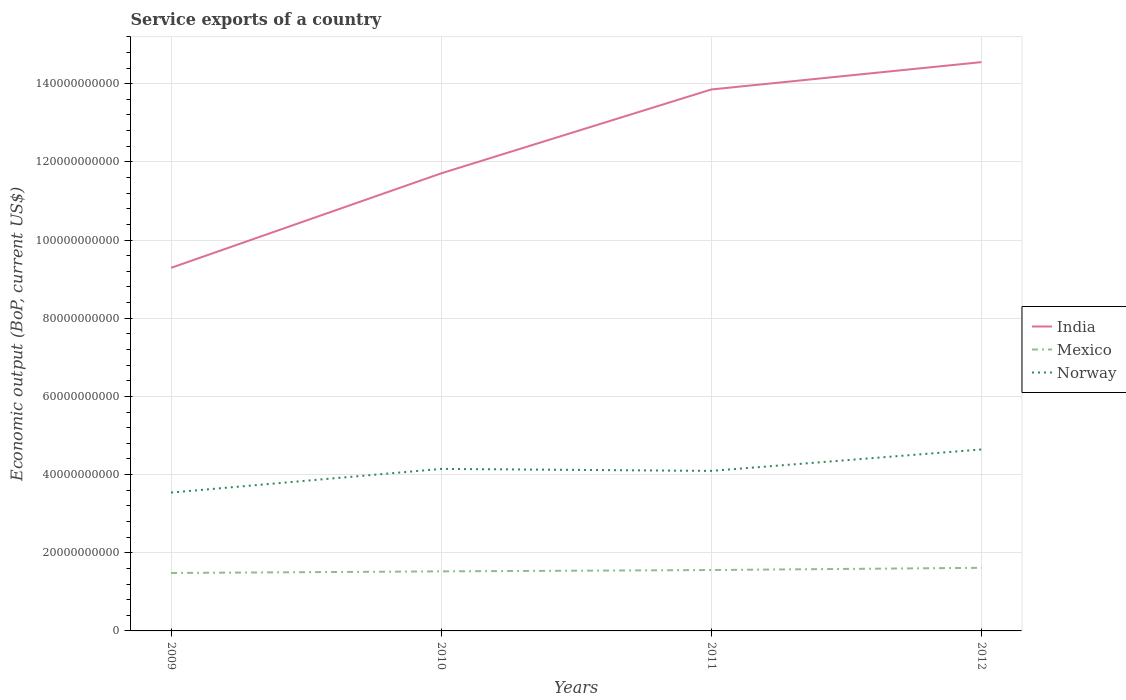How many different coloured lines are there?
Give a very brief answer. 3. Does the line corresponding to Mexico intersect with the line corresponding to India?
Your answer should be compact. No. Across all years, what is the maximum service exports in Norway?
Your answer should be very brief. 3.54e+1. In which year was the service exports in India maximum?
Your response must be concise. 2009. What is the total service exports in India in the graph?
Make the answer very short. -2.85e+1. What is the difference between the highest and the second highest service exports in Norway?
Provide a succinct answer. 1.10e+1. Is the service exports in India strictly greater than the service exports in Mexico over the years?
Make the answer very short. No. How many lines are there?
Your answer should be compact. 3. What is the difference between two consecutive major ticks on the Y-axis?
Your answer should be compact. 2.00e+1. Does the graph contain any zero values?
Keep it short and to the point. No. Does the graph contain grids?
Your response must be concise. Yes. Where does the legend appear in the graph?
Your response must be concise. Center right. How are the legend labels stacked?
Keep it short and to the point. Vertical. What is the title of the graph?
Offer a very short reply. Service exports of a country. What is the label or title of the Y-axis?
Give a very brief answer. Economic output (BoP, current US$). What is the Economic output (BoP, current US$) in India in 2009?
Keep it short and to the point. 9.29e+1. What is the Economic output (BoP, current US$) of Mexico in 2009?
Your answer should be compact. 1.48e+1. What is the Economic output (BoP, current US$) in Norway in 2009?
Ensure brevity in your answer.  3.54e+1. What is the Economic output (BoP, current US$) in India in 2010?
Provide a short and direct response. 1.17e+11. What is the Economic output (BoP, current US$) of Mexico in 2010?
Provide a short and direct response. 1.52e+1. What is the Economic output (BoP, current US$) of Norway in 2010?
Keep it short and to the point. 4.15e+1. What is the Economic output (BoP, current US$) in India in 2011?
Your answer should be compact. 1.39e+11. What is the Economic output (BoP, current US$) in Mexico in 2011?
Your answer should be very brief. 1.56e+1. What is the Economic output (BoP, current US$) of Norway in 2011?
Your response must be concise. 4.09e+1. What is the Economic output (BoP, current US$) of India in 2012?
Provide a succinct answer. 1.46e+11. What is the Economic output (BoP, current US$) of Mexico in 2012?
Provide a short and direct response. 1.61e+1. What is the Economic output (BoP, current US$) in Norway in 2012?
Provide a short and direct response. 4.64e+1. Across all years, what is the maximum Economic output (BoP, current US$) in India?
Make the answer very short. 1.46e+11. Across all years, what is the maximum Economic output (BoP, current US$) in Mexico?
Keep it short and to the point. 1.61e+1. Across all years, what is the maximum Economic output (BoP, current US$) in Norway?
Your response must be concise. 4.64e+1. Across all years, what is the minimum Economic output (BoP, current US$) in India?
Provide a succinct answer. 9.29e+1. Across all years, what is the minimum Economic output (BoP, current US$) in Mexico?
Provide a short and direct response. 1.48e+1. Across all years, what is the minimum Economic output (BoP, current US$) of Norway?
Make the answer very short. 3.54e+1. What is the total Economic output (BoP, current US$) of India in the graph?
Your answer should be compact. 4.94e+11. What is the total Economic output (BoP, current US$) in Mexico in the graph?
Provide a succinct answer. 6.18e+1. What is the total Economic output (BoP, current US$) in Norway in the graph?
Offer a terse response. 1.64e+11. What is the difference between the Economic output (BoP, current US$) of India in 2009 and that in 2010?
Offer a very short reply. -2.42e+1. What is the difference between the Economic output (BoP, current US$) of Mexico in 2009 and that in 2010?
Provide a short and direct response. -4.10e+08. What is the difference between the Economic output (BoP, current US$) in Norway in 2009 and that in 2010?
Make the answer very short. -6.06e+09. What is the difference between the Economic output (BoP, current US$) in India in 2009 and that in 2011?
Give a very brief answer. -4.56e+1. What is the difference between the Economic output (BoP, current US$) in Mexico in 2009 and that in 2011?
Your answer should be very brief. -7.58e+08. What is the difference between the Economic output (BoP, current US$) in Norway in 2009 and that in 2011?
Give a very brief answer. -5.54e+09. What is the difference between the Economic output (BoP, current US$) of India in 2009 and that in 2012?
Your answer should be very brief. -5.26e+1. What is the difference between the Economic output (BoP, current US$) of Mexico in 2009 and that in 2012?
Offer a terse response. -1.32e+09. What is the difference between the Economic output (BoP, current US$) of Norway in 2009 and that in 2012?
Your answer should be compact. -1.10e+1. What is the difference between the Economic output (BoP, current US$) of India in 2010 and that in 2011?
Offer a very short reply. -2.15e+1. What is the difference between the Economic output (BoP, current US$) in Mexico in 2010 and that in 2011?
Make the answer very short. -3.47e+08. What is the difference between the Economic output (BoP, current US$) of Norway in 2010 and that in 2011?
Provide a succinct answer. 5.11e+08. What is the difference between the Economic output (BoP, current US$) of India in 2010 and that in 2012?
Your answer should be compact. -2.85e+1. What is the difference between the Economic output (BoP, current US$) of Mexico in 2010 and that in 2012?
Make the answer very short. -9.11e+08. What is the difference between the Economic output (BoP, current US$) in Norway in 2010 and that in 2012?
Provide a succinct answer. -4.97e+09. What is the difference between the Economic output (BoP, current US$) in India in 2011 and that in 2012?
Your answer should be very brief. -7.00e+09. What is the difference between the Economic output (BoP, current US$) in Mexico in 2011 and that in 2012?
Make the answer very short. -5.64e+08. What is the difference between the Economic output (BoP, current US$) in Norway in 2011 and that in 2012?
Your answer should be very brief. -5.48e+09. What is the difference between the Economic output (BoP, current US$) of India in 2009 and the Economic output (BoP, current US$) of Mexico in 2010?
Give a very brief answer. 7.77e+1. What is the difference between the Economic output (BoP, current US$) in India in 2009 and the Economic output (BoP, current US$) in Norway in 2010?
Provide a short and direct response. 5.14e+1. What is the difference between the Economic output (BoP, current US$) in Mexico in 2009 and the Economic output (BoP, current US$) in Norway in 2010?
Offer a terse response. -2.66e+1. What is the difference between the Economic output (BoP, current US$) in India in 2009 and the Economic output (BoP, current US$) in Mexico in 2011?
Offer a very short reply. 7.73e+1. What is the difference between the Economic output (BoP, current US$) of India in 2009 and the Economic output (BoP, current US$) of Norway in 2011?
Provide a succinct answer. 5.19e+1. What is the difference between the Economic output (BoP, current US$) in Mexico in 2009 and the Economic output (BoP, current US$) in Norway in 2011?
Keep it short and to the point. -2.61e+1. What is the difference between the Economic output (BoP, current US$) of India in 2009 and the Economic output (BoP, current US$) of Mexico in 2012?
Give a very brief answer. 7.67e+1. What is the difference between the Economic output (BoP, current US$) in India in 2009 and the Economic output (BoP, current US$) in Norway in 2012?
Provide a succinct answer. 4.65e+1. What is the difference between the Economic output (BoP, current US$) of Mexico in 2009 and the Economic output (BoP, current US$) of Norway in 2012?
Keep it short and to the point. -3.16e+1. What is the difference between the Economic output (BoP, current US$) of India in 2010 and the Economic output (BoP, current US$) of Mexico in 2011?
Provide a short and direct response. 1.01e+11. What is the difference between the Economic output (BoP, current US$) in India in 2010 and the Economic output (BoP, current US$) in Norway in 2011?
Provide a succinct answer. 7.61e+1. What is the difference between the Economic output (BoP, current US$) of Mexico in 2010 and the Economic output (BoP, current US$) of Norway in 2011?
Your answer should be very brief. -2.57e+1. What is the difference between the Economic output (BoP, current US$) of India in 2010 and the Economic output (BoP, current US$) of Mexico in 2012?
Your answer should be very brief. 1.01e+11. What is the difference between the Economic output (BoP, current US$) of India in 2010 and the Economic output (BoP, current US$) of Norway in 2012?
Offer a terse response. 7.06e+1. What is the difference between the Economic output (BoP, current US$) of Mexico in 2010 and the Economic output (BoP, current US$) of Norway in 2012?
Provide a short and direct response. -3.12e+1. What is the difference between the Economic output (BoP, current US$) in India in 2011 and the Economic output (BoP, current US$) in Mexico in 2012?
Make the answer very short. 1.22e+11. What is the difference between the Economic output (BoP, current US$) in India in 2011 and the Economic output (BoP, current US$) in Norway in 2012?
Provide a short and direct response. 9.21e+1. What is the difference between the Economic output (BoP, current US$) in Mexico in 2011 and the Economic output (BoP, current US$) in Norway in 2012?
Your answer should be very brief. -3.08e+1. What is the average Economic output (BoP, current US$) in India per year?
Make the answer very short. 1.24e+11. What is the average Economic output (BoP, current US$) of Mexico per year?
Provide a short and direct response. 1.54e+1. What is the average Economic output (BoP, current US$) in Norway per year?
Ensure brevity in your answer.  4.11e+1. In the year 2009, what is the difference between the Economic output (BoP, current US$) of India and Economic output (BoP, current US$) of Mexico?
Provide a short and direct response. 7.81e+1. In the year 2009, what is the difference between the Economic output (BoP, current US$) in India and Economic output (BoP, current US$) in Norway?
Offer a terse response. 5.75e+1. In the year 2009, what is the difference between the Economic output (BoP, current US$) in Mexico and Economic output (BoP, current US$) in Norway?
Keep it short and to the point. -2.06e+1. In the year 2010, what is the difference between the Economic output (BoP, current US$) in India and Economic output (BoP, current US$) in Mexico?
Your answer should be very brief. 1.02e+11. In the year 2010, what is the difference between the Economic output (BoP, current US$) of India and Economic output (BoP, current US$) of Norway?
Keep it short and to the point. 7.56e+1. In the year 2010, what is the difference between the Economic output (BoP, current US$) of Mexico and Economic output (BoP, current US$) of Norway?
Your response must be concise. -2.62e+1. In the year 2011, what is the difference between the Economic output (BoP, current US$) in India and Economic output (BoP, current US$) in Mexico?
Provide a succinct answer. 1.23e+11. In the year 2011, what is the difference between the Economic output (BoP, current US$) of India and Economic output (BoP, current US$) of Norway?
Offer a terse response. 9.76e+1. In the year 2011, what is the difference between the Economic output (BoP, current US$) of Mexico and Economic output (BoP, current US$) of Norway?
Ensure brevity in your answer.  -2.54e+1. In the year 2012, what is the difference between the Economic output (BoP, current US$) in India and Economic output (BoP, current US$) in Mexico?
Offer a terse response. 1.29e+11. In the year 2012, what is the difference between the Economic output (BoP, current US$) of India and Economic output (BoP, current US$) of Norway?
Your answer should be very brief. 9.91e+1. In the year 2012, what is the difference between the Economic output (BoP, current US$) of Mexico and Economic output (BoP, current US$) of Norway?
Make the answer very short. -3.03e+1. What is the ratio of the Economic output (BoP, current US$) in India in 2009 to that in 2010?
Offer a very short reply. 0.79. What is the ratio of the Economic output (BoP, current US$) of Mexico in 2009 to that in 2010?
Offer a terse response. 0.97. What is the ratio of the Economic output (BoP, current US$) of Norway in 2009 to that in 2010?
Your answer should be compact. 0.85. What is the ratio of the Economic output (BoP, current US$) in India in 2009 to that in 2011?
Provide a succinct answer. 0.67. What is the ratio of the Economic output (BoP, current US$) of Mexico in 2009 to that in 2011?
Your answer should be very brief. 0.95. What is the ratio of the Economic output (BoP, current US$) of Norway in 2009 to that in 2011?
Keep it short and to the point. 0.86. What is the ratio of the Economic output (BoP, current US$) of India in 2009 to that in 2012?
Your answer should be very brief. 0.64. What is the ratio of the Economic output (BoP, current US$) in Mexico in 2009 to that in 2012?
Keep it short and to the point. 0.92. What is the ratio of the Economic output (BoP, current US$) in Norway in 2009 to that in 2012?
Offer a very short reply. 0.76. What is the ratio of the Economic output (BoP, current US$) of India in 2010 to that in 2011?
Your answer should be very brief. 0.85. What is the ratio of the Economic output (BoP, current US$) in Mexico in 2010 to that in 2011?
Your answer should be very brief. 0.98. What is the ratio of the Economic output (BoP, current US$) in Norway in 2010 to that in 2011?
Offer a very short reply. 1.01. What is the ratio of the Economic output (BoP, current US$) in India in 2010 to that in 2012?
Offer a terse response. 0.8. What is the ratio of the Economic output (BoP, current US$) in Mexico in 2010 to that in 2012?
Offer a terse response. 0.94. What is the ratio of the Economic output (BoP, current US$) of Norway in 2010 to that in 2012?
Offer a very short reply. 0.89. What is the ratio of the Economic output (BoP, current US$) of India in 2011 to that in 2012?
Keep it short and to the point. 0.95. What is the ratio of the Economic output (BoP, current US$) of Mexico in 2011 to that in 2012?
Your response must be concise. 0.97. What is the ratio of the Economic output (BoP, current US$) in Norway in 2011 to that in 2012?
Keep it short and to the point. 0.88. What is the difference between the highest and the second highest Economic output (BoP, current US$) in India?
Provide a succinct answer. 7.00e+09. What is the difference between the highest and the second highest Economic output (BoP, current US$) of Mexico?
Give a very brief answer. 5.64e+08. What is the difference between the highest and the second highest Economic output (BoP, current US$) in Norway?
Provide a succinct answer. 4.97e+09. What is the difference between the highest and the lowest Economic output (BoP, current US$) of India?
Keep it short and to the point. 5.26e+1. What is the difference between the highest and the lowest Economic output (BoP, current US$) in Mexico?
Keep it short and to the point. 1.32e+09. What is the difference between the highest and the lowest Economic output (BoP, current US$) in Norway?
Keep it short and to the point. 1.10e+1. 